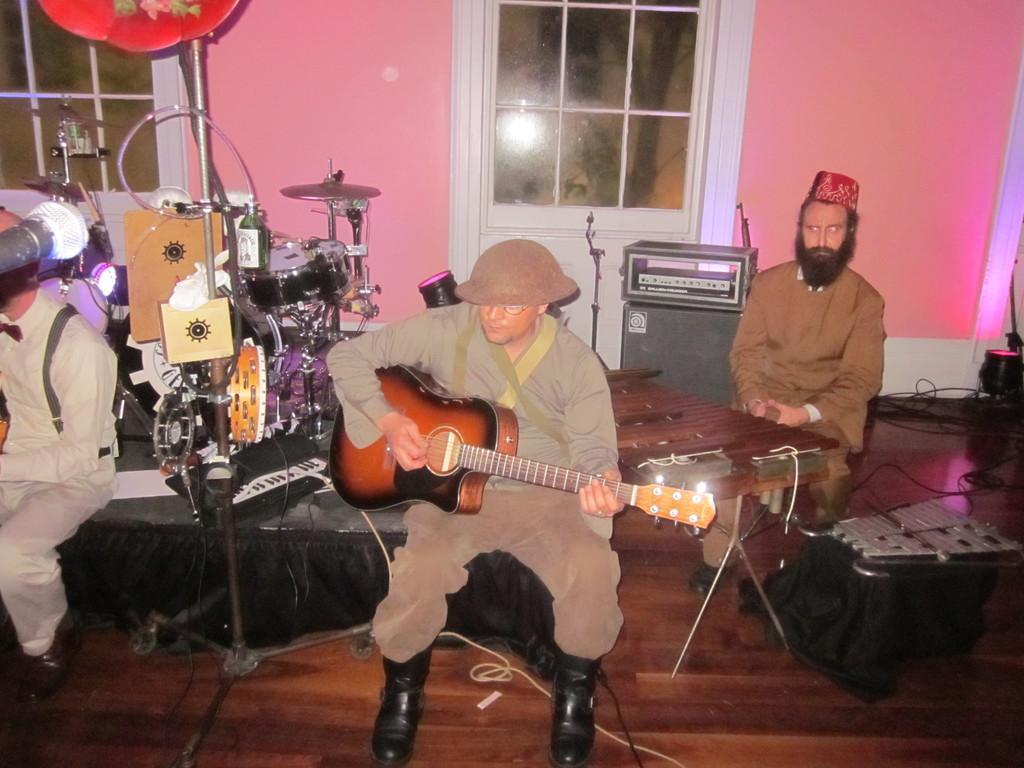Could you give a brief overview of what you see in this image? In this picture we can see a man who is playing guitar. These are some musical instruments. Here we can see two persons are sitting on the chairs. This is floor. On the background there is a wall and this is window. 